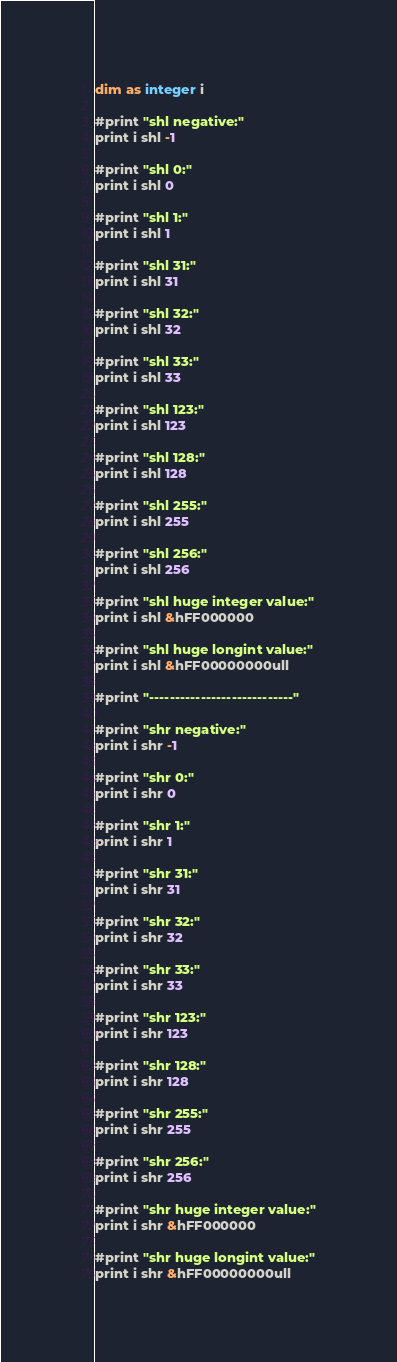<code> <loc_0><loc_0><loc_500><loc_500><_VisualBasic_>dim as integer i

#print "shl negative:"
print i shl -1

#print "shl 0:"
print i shl 0

#print "shl 1:"
print i shl 1

#print "shl 31:"
print i shl 31

#print "shl 32:"
print i shl 32

#print "shl 33:"
print i shl 33

#print "shl 123:"
print i shl 123

#print "shl 128:"
print i shl 128

#print "shl 255:"
print i shl 255

#print "shl 256:"
print i shl 256

#print "shl huge integer value:"
print i shl &hFF000000

#print "shl huge longint value:"
print i shl &hFF00000000ull

#print "----------------------------"

#print "shr negative:"
print i shr -1

#print "shr 0:"
print i shr 0

#print "shr 1:"
print i shr 1

#print "shr 31:"
print i shr 31

#print "shr 32:"
print i shr 32

#print "shr 33:"
print i shr 33

#print "shr 123:"
print i shr 123

#print "shr 128:"
print i shr 128

#print "shr 255:"
print i shr 255

#print "shr 256:"
print i shr 256

#print "shr huge integer value:"
print i shr &hFF000000

#print "shr huge longint value:"
print i shr &hFF00000000ull
</code> 